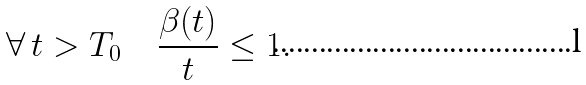Convert formula to latex. <formula><loc_0><loc_0><loc_500><loc_500>\forall \, t > T _ { 0 } \quad \frac { \beta ( t ) } { t } \leq 1 .</formula> 